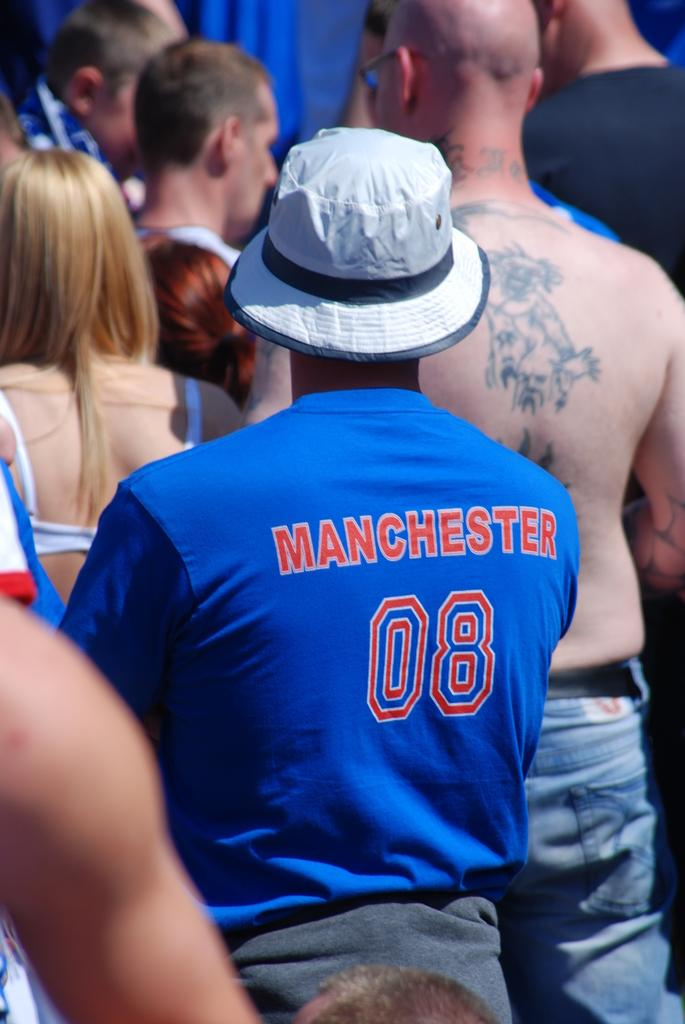<image>
Write a terse but informative summary of the picture. A man in a white hat stands in a crowd with his back to us wearing a blue top with Manchester 08 on the back. 